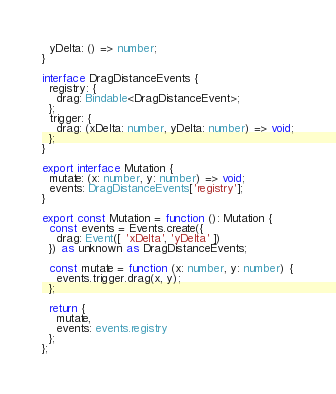<code> <loc_0><loc_0><loc_500><loc_500><_TypeScript_>  yDelta: () => number;
}

interface DragDistanceEvents {
  registry: {
    drag: Bindable<DragDistanceEvent>;
  };
  trigger: {
    drag: (xDelta: number, yDelta: number) => void;
  };
}

export interface Mutation {
  mutate: (x: number, y: number) => void;
  events: DragDistanceEvents['registry'];
}

export const Mutation = function (): Mutation {
  const events = Events.create({
    drag: Event([ 'xDelta', 'yDelta' ])
  }) as unknown as DragDistanceEvents;

  const mutate = function (x: number, y: number) {
    events.trigger.drag(x, y);
  };

  return {
    mutate,
    events: events.registry
  };
};</code> 